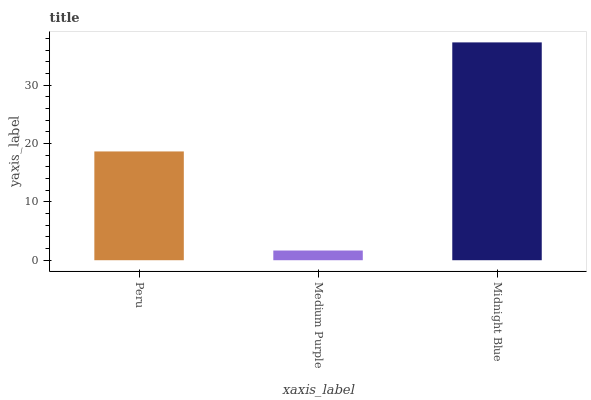Is Medium Purple the minimum?
Answer yes or no. Yes. Is Midnight Blue the maximum?
Answer yes or no. Yes. Is Midnight Blue the minimum?
Answer yes or no. No. Is Medium Purple the maximum?
Answer yes or no. No. Is Midnight Blue greater than Medium Purple?
Answer yes or no. Yes. Is Medium Purple less than Midnight Blue?
Answer yes or no. Yes. Is Medium Purple greater than Midnight Blue?
Answer yes or no. No. Is Midnight Blue less than Medium Purple?
Answer yes or no. No. Is Peru the high median?
Answer yes or no. Yes. Is Peru the low median?
Answer yes or no. Yes. Is Medium Purple the high median?
Answer yes or no. No. Is Midnight Blue the low median?
Answer yes or no. No. 